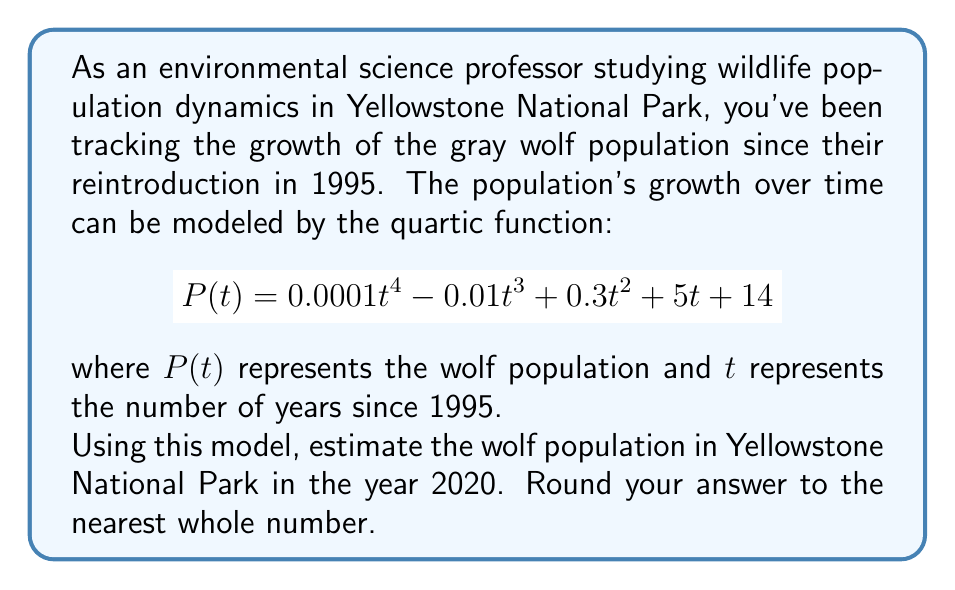Give your solution to this math problem. To solve this problem, we need to follow these steps:

1. Identify the value of $t$ for the year 2020:
   The year 2020 is 25 years after 1995, so $t = 25$.

2. Substitute $t = 25$ into the quartic function:
   $$P(25) = 0.0001(25)^4 - 0.01(25)^3 + 0.3(25)^2 + 5(25) + 14$$

3. Calculate each term:
   $$\begin{align*}
   0.0001(25)^4 &= 0.0001 \times 390625 = 39.0625 \\
   -0.01(25)^3 &= -0.01 \times 15625 = -156.25 \\
   0.3(25)^2 &= 0.3 \times 625 = 187.5 \\
   5(25) &= 125 \\
   14 &= 14
   \end{align*}$$

4. Sum up all the terms:
   $$P(25) = 39.0625 - 156.25 + 187.5 + 125 + 14 = 209.3125$$

5. Round to the nearest whole number:
   209.3125 rounds to 209.

Therefore, the estimated wolf population in Yellowstone National Park in 2020 is 209 wolves.
Answer: 209 wolves 